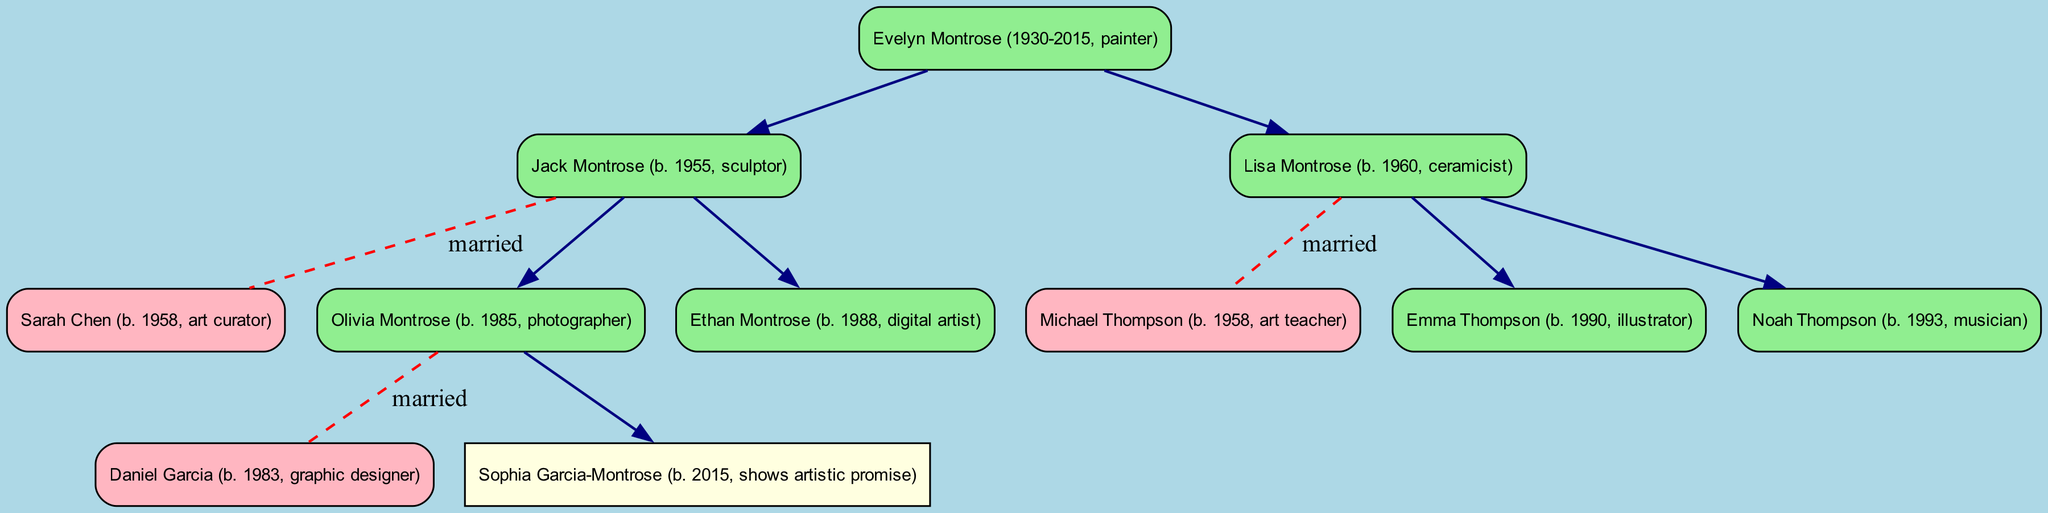What is the name of the root person in the family tree? The root person is the one at the top of the tree. According to the diagram, the root person is Evelyn Montrose (1930-2015, painter).
Answer: Evelyn Montrose (1930-2015, painter) How many children does Jack Montrose have? By counting the children listed under Jack Montrose, we see that he has two children: Olivia Montrose and Ethan Montrose.
Answer: 2 What is the profession of Lisa Montrose? The profession is listed next to the name of Lisa Montrose in the tree. Lisa Montrose is identified as a ceramicist.
Answer: ceramicist Who is the spouse of Olivia Montrose? Olivia Montrose's spouse is directly mentioned in the tree. The spouse listed is Daniel Garcia.
Answer: Daniel Garcia How many grandchildren does Evelyn Montrose have? To determine the number of grandchildren, we look at all the children of her children. Evelyn has one grandchild from Olivia (Sophia Garcia-Montrose) and two grandchildren from Lisa (Emma Thompson and Noah Thompson). Therefore, total grandchildren are three.
Answer: 3 Which profession does Noah Thompson have? By examining the diagram, we find the profession listed next to Noah Thompson, and it states that he is a musician.
Answer: musician What is the relationship between Olivia Montrose and Ethan Montrose? The relationship can be determined by their positioning as children of the same parent, Jack Montrose. Since they share the same parent, they are siblings.
Answer: siblings How many married couples are shown in the diagram? By counting each pair of names that are connected with a marriage label, we can see that there are three married couples in the diagram: Jack and Sarah, Lisa and Michael, and Olivia and Daniel.
Answer: 3 What artistic talent is shown by Sophia Garcia-Montrose? In the diagram, under Sophia Garcia-Montrose, it is noted that she shows artistic promise. This indicates her potential in the arts, aligning with the family's creative lineage.
Answer: shows artistic promise 